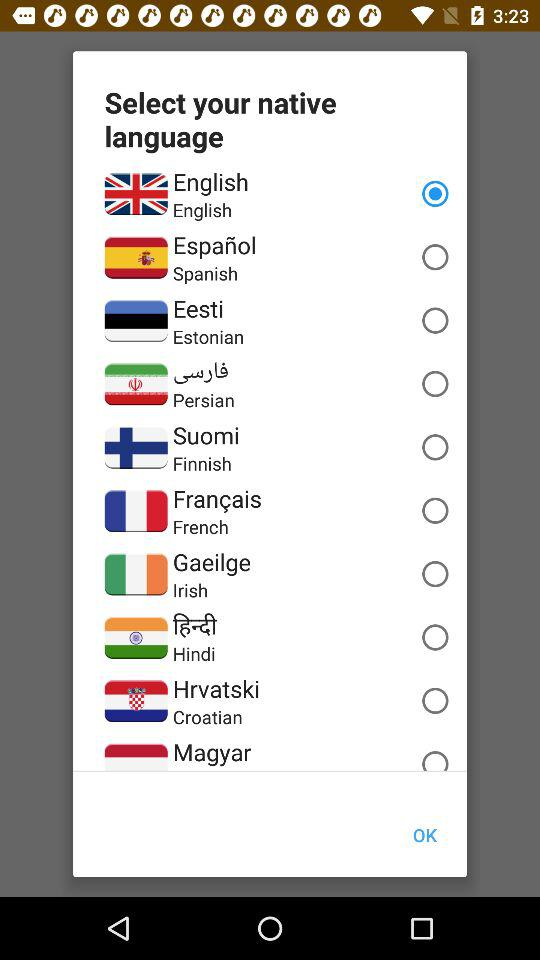How many languages are available to choose from?
Answer the question using a single word or phrase. 10 